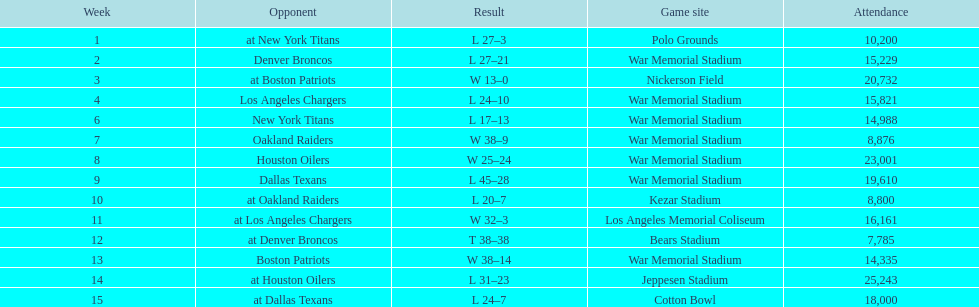After their match with the oakland raiders, who were the bills up against? Houston Oilers. 